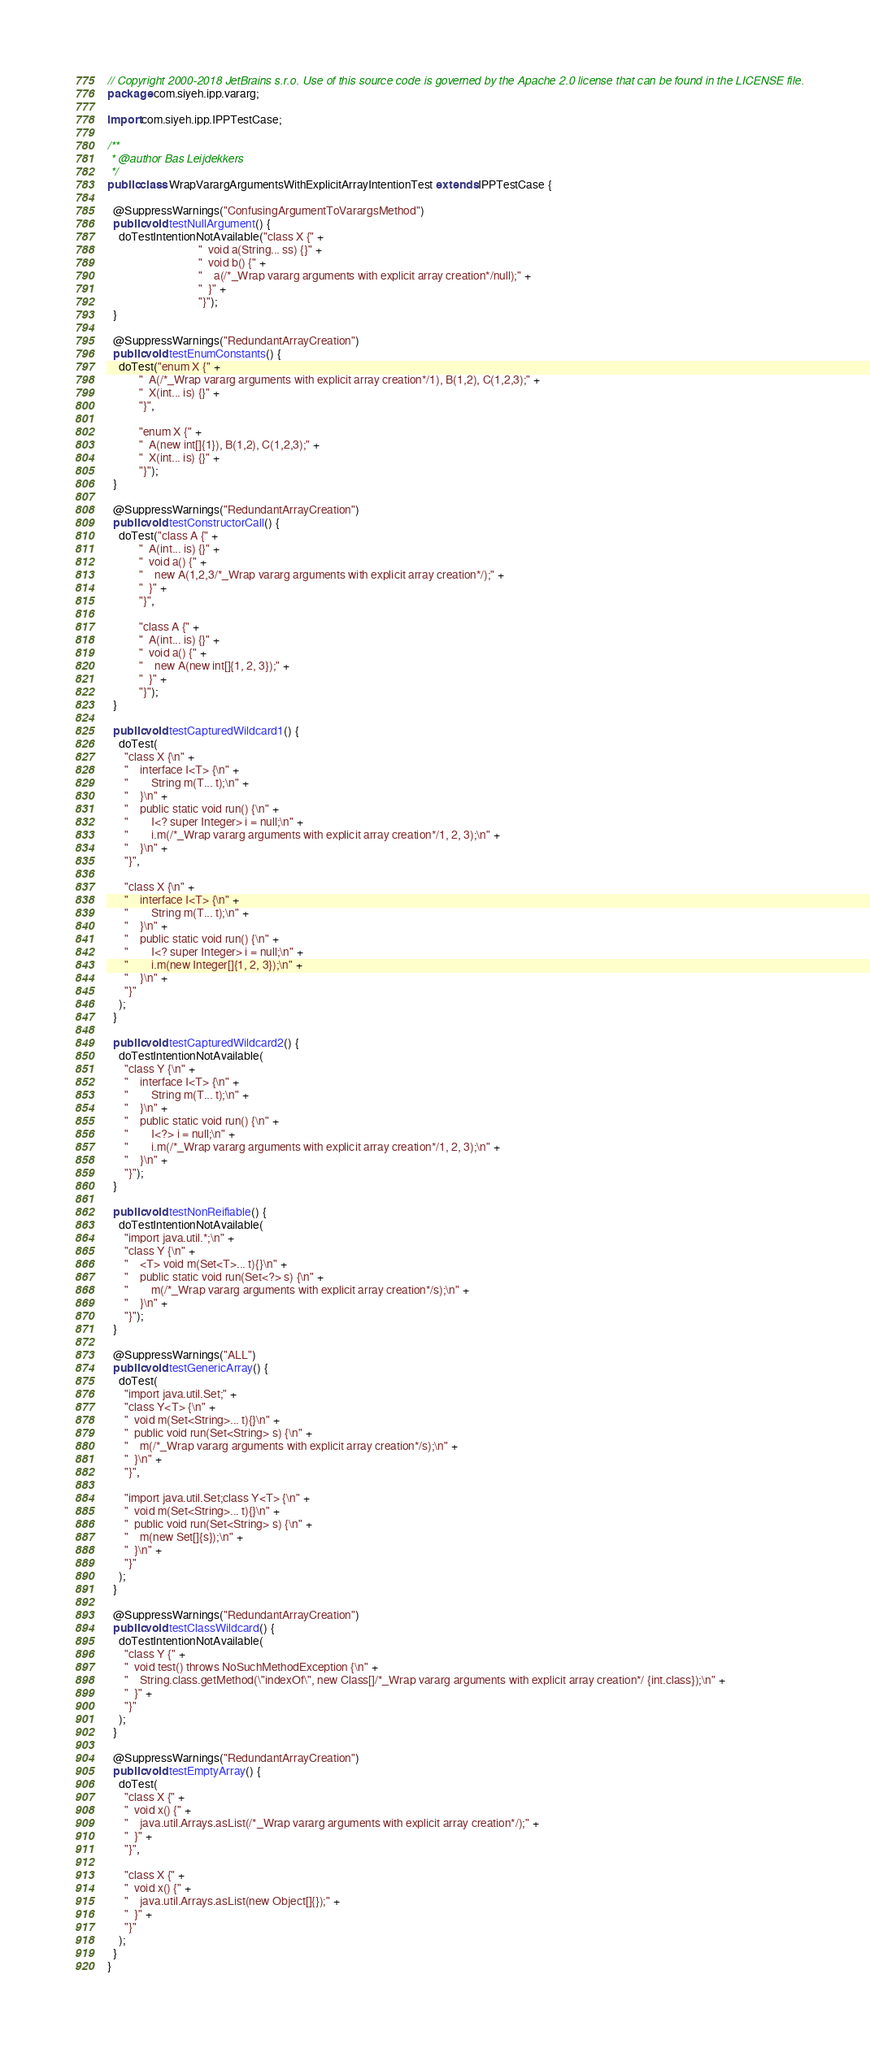<code> <loc_0><loc_0><loc_500><loc_500><_Java_>// Copyright 2000-2018 JetBrains s.r.o. Use of this source code is governed by the Apache 2.0 license that can be found in the LICENSE file.
package com.siyeh.ipp.vararg;

import com.siyeh.ipp.IPPTestCase;

/**
 * @author Bas Leijdekkers
 */
public class WrapVarargArgumentsWithExplicitArrayIntentionTest extends IPPTestCase {

  @SuppressWarnings("ConfusingArgumentToVarargsMethod")
  public void testNullArgument() {
    doTestIntentionNotAvailable("class X {" +
                                "  void a(String... ss) {}" +
                                "  void b() {" +
                                "    a(/*_Wrap vararg arguments with explicit array creation*/null);" +
                                "  }" +
                                "}");
  }

  @SuppressWarnings("RedundantArrayCreation")
  public void testEnumConstants() {
    doTest("enum X {" +
           "  A(/*_Wrap vararg arguments with explicit array creation*/1), B(1,2), C(1,2,3);" +
           "  X(int... is) {}" +
           "}",

           "enum X {" +
           "  A(new int[]{1}), B(1,2), C(1,2,3);" +
           "  X(int... is) {}" +
           "}");
  }

  @SuppressWarnings("RedundantArrayCreation")
  public void testConstructorCall() {
    doTest("class A {" +
           "  A(int... is) {}" +
           "  void a() {" +
           "    new A(1,2,3/*_Wrap vararg arguments with explicit array creation*/);" +
           "  }" +
           "}",

           "class A {" +
           "  A(int... is) {}" +
           "  void a() {" +
           "    new A(new int[]{1, 2, 3});" +
           "  }" +
           "}");
  }

  public void testCapturedWildcard1() {
    doTest(
      "class X {\n" +
      "    interface I<T> {\n" +
      "        String m(T... t);\n" +
      "    }\n" +
      "    public static void run() {\n" +
      "        I<? super Integer> i = null;\n" +
      "        i.m(/*_Wrap vararg arguments with explicit array creation*/1, 2, 3);\n" +
      "    }\n" +
      "}",

      "class X {\n" +
      "    interface I<T> {\n" +
      "        String m(T... t);\n" +
      "    }\n" +
      "    public static void run() {\n" +
      "        I<? super Integer> i = null;\n" +
      "        i.m(new Integer[]{1, 2, 3});\n" +
      "    }\n" +
      "}"
    );
  }

  public void testCapturedWildcard2() {
    doTestIntentionNotAvailable(
      "class Y {\n" +
      "    interface I<T> {\n" +
      "        String m(T... t);\n" +
      "    }\n" +
      "    public static void run() {\n" +
      "        I<?> i = null;\n" +
      "        i.m(/*_Wrap vararg arguments with explicit array creation*/1, 2, 3);\n" +
      "    }\n" +
      "}");
  }
  
  public void testNonReifiable() {
    doTestIntentionNotAvailable(
      "import java.util.*;\n" +
      "class Y {\n" +
      "    <T> void m(Set<T>... t){}\n" +
      "    public static void run(Set<?> s) {\n" +
      "        m(/*_Wrap vararg arguments with explicit array creation*/s);\n" +
      "    }\n" +
      "}");
  }

  @SuppressWarnings("ALL")
  public void testGenericArray() {
    doTest(
      "import java.util.Set;" +
      "class Y<T> {\n" +
      "  void m(Set<String>... t){}\n" +
      "  public void run(Set<String> s) {\n" +
      "    m(/*_Wrap vararg arguments with explicit array creation*/s);\n" +
      "  }\n" +
      "}",

      "import java.util.Set;class Y<T> {\n" +
      "  void m(Set<String>... t){}\n" +
      "  public void run(Set<String> s) {\n" +
      "    m(new Set[]{s});\n" +
      "  }\n" +
      "}"
    );
  }

  @SuppressWarnings("RedundantArrayCreation")
  public void testClassWildcard() {
    doTestIntentionNotAvailable(
      "class Y {" +
      "  void test() throws NoSuchMethodException {\n" +
      "    String.class.getMethod(\"indexOf\", new Class[]/*_Wrap vararg arguments with explicit array creation*/ {int.class});\n" +
      "  }" +
      "}"
    );
  }

  @SuppressWarnings("RedundantArrayCreation")
  public void testEmptyArray() {
    doTest(
      "class X {" +
      "  void x() {" +
      "    java.util.Arrays.asList(/*_Wrap vararg arguments with explicit array creation*/);" +
      "  }" +
      "}",

      "class X {" +
      "  void x() {" +
      "    java.util.Arrays.asList(new Object[]{});" +
      "  }" +
      "}"
    );
  }
}
</code> 